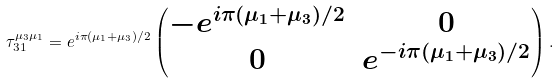Convert formula to latex. <formula><loc_0><loc_0><loc_500><loc_500>\tau _ { 3 1 } ^ { \mu _ { 3 } \mu _ { 1 } } = e ^ { i \pi ( \mu _ { 1 } + \mu _ { 3 } ) / 2 } \left ( \begin{matrix} - e ^ { i \pi ( \mu _ { 1 } + \mu _ { 3 } ) / 2 } & 0 \\ 0 & e ^ { - i \pi ( \mu _ { 1 } + \mu _ { 3 } ) / 2 } \end{matrix} \right ) .</formula> 